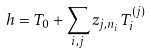<formula> <loc_0><loc_0><loc_500><loc_500>h = T _ { 0 } + \sum _ { i , j } z _ { j , n _ { i } } T ^ { ( j ) } _ { i }</formula> 